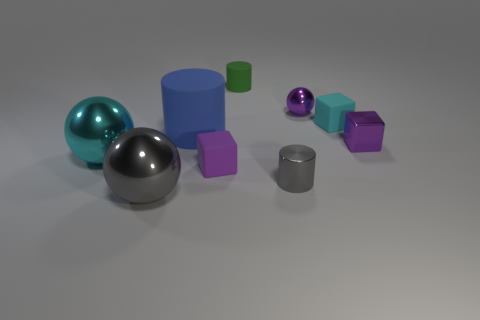How many purple cubes must be subtracted to get 1 purple cubes? 1 Add 1 large purple metallic cubes. How many objects exist? 10 Subtract all cubes. How many objects are left? 6 Subtract all tiny metallic blocks. Subtract all blue objects. How many objects are left? 7 Add 8 tiny gray cylinders. How many tiny gray cylinders are left? 9 Add 6 small shiny spheres. How many small shiny spheres exist? 7 Subtract 1 green cylinders. How many objects are left? 8 